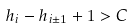<formula> <loc_0><loc_0><loc_500><loc_500>h _ { i } - h _ { i \pm 1 } + 1 > C</formula> 